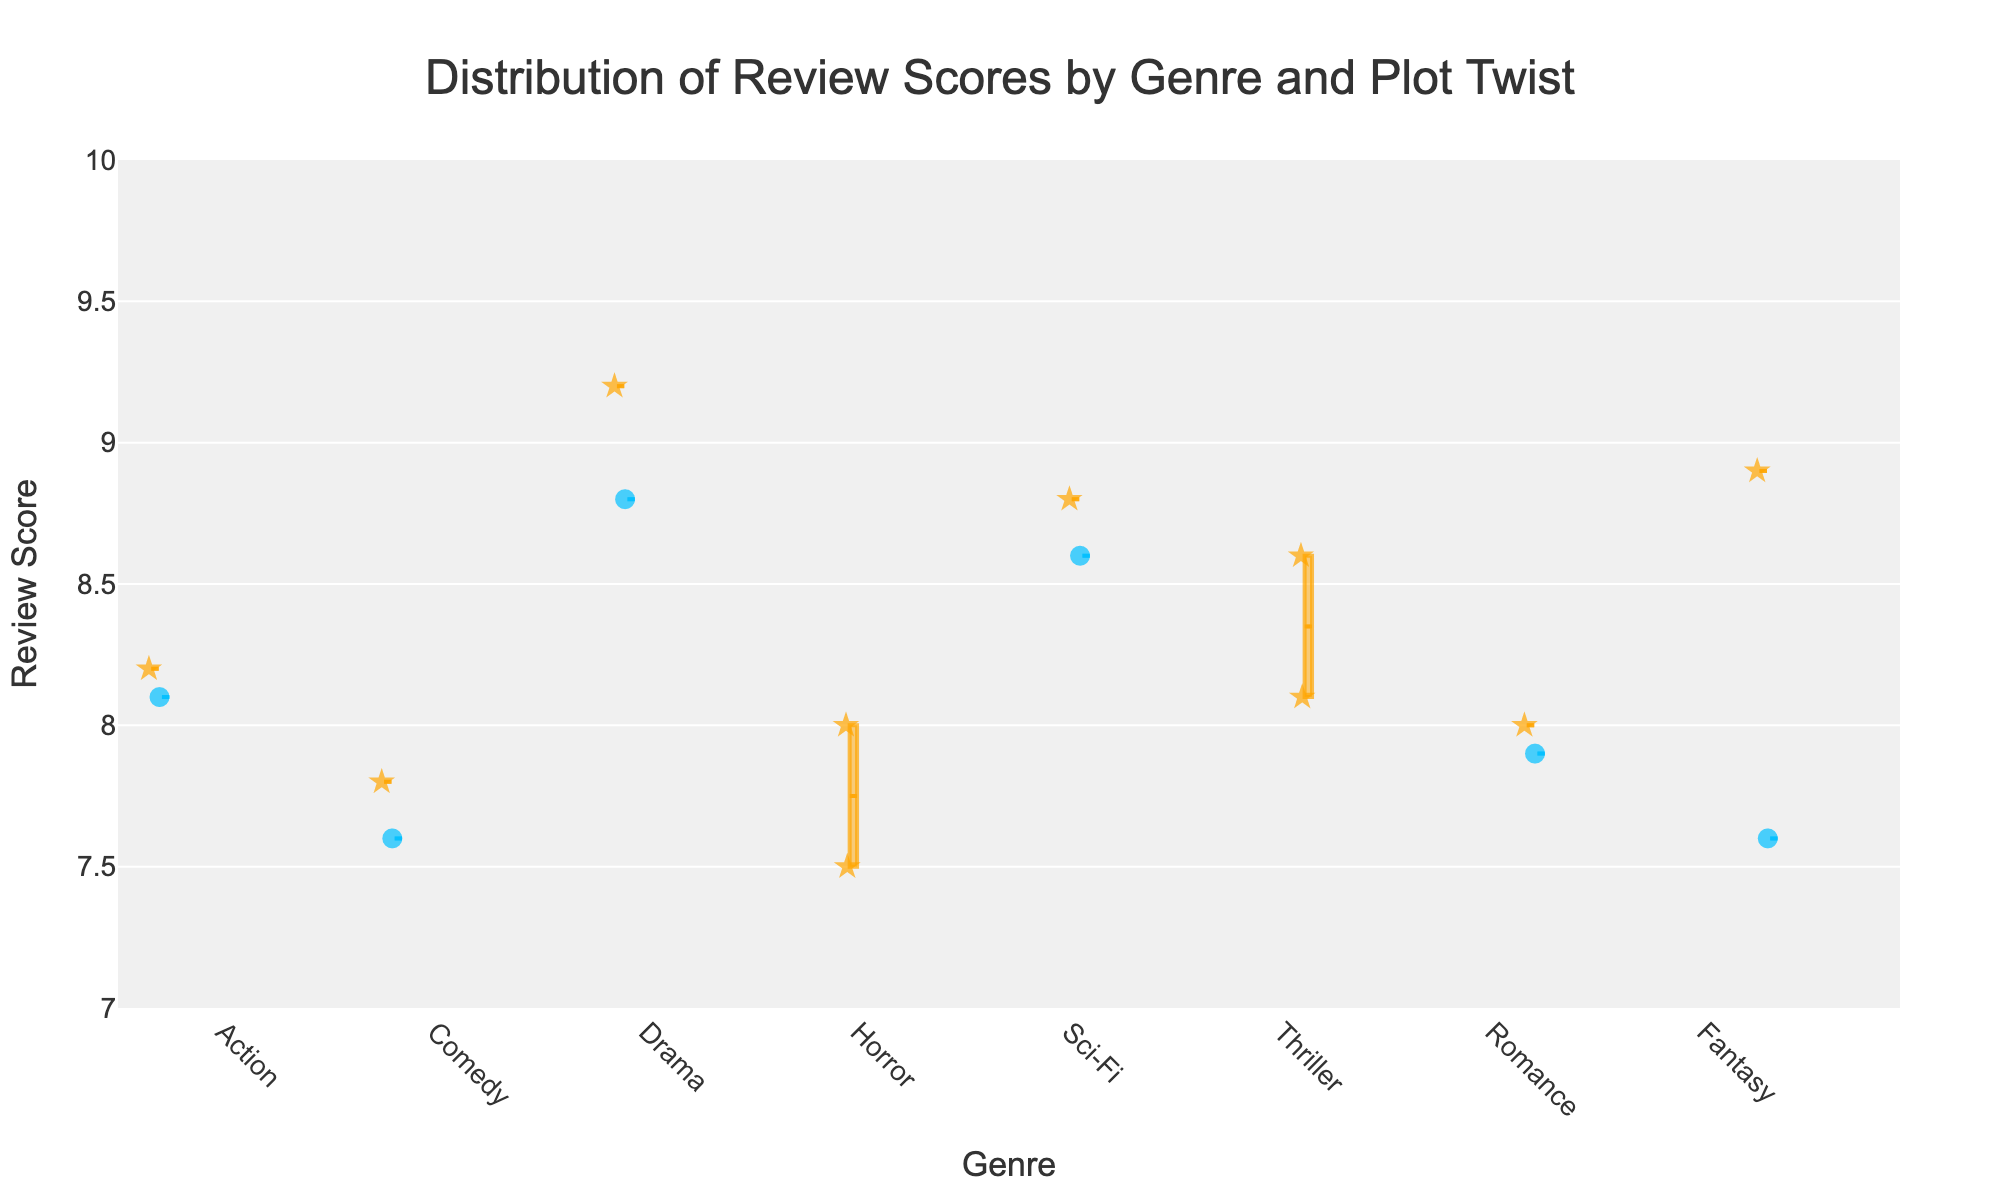What is the overall title of the figure? The title is usually found at the top of the figure, summarizing its content. In this case, the title is centered and reads: "Distribution of Review Scores by Genre and Plot Twist".
Answer: Distribution of Review Scores by Genre and Plot Twist What are the two possible categories for the legend item "Contains Plot Twist"? The legend indicates the categories for whether a film has a plot twist or not. These categories are shown as "Yes" and "No".
Answer: Yes, No What color represents films with plot twists? The figure uses different colors to distinguish between films with and without plot twists. Films with plot twists are marked with an orange shade.
Answer: Orange Which genre has the highest median review score for films with plot twists? To find the genre with the highest median review score for films with plot twists, look at the central line within the orange-colored boxes. The Drama genre, represented by The Godfather (9.2), has the highest median.
Answer: Drama How do review scores for films without plot twists compare across genres? For comparison, look at the blue-colored boxes and their positions along the Review Score axis. Sci-Fi (8.6 median for Interstellar) and Drama (8.8 median for Forrest Gump) are the highest without plot twists.
Answer: Sci-Fi and Drama What is the range of review scores for the Comedy genre with plot twists? Look at the box representing Comedy in the orange shade. The box's upper and lower extremes depict the range of review scores; here, it ranges between 7.6 and 7.8.
Answer: 7.6 to 7.8 Which genre shows the greatest spread in review scores for films with plot twists? The spread is observed by looking at the length of the boxes. In this figure, the Thriller genre shows the broadest spread, spanning from the lower whisker (around 8.1) to the upper whisker (around 8.6).
Answer: Thriller Which genre has a more consistent review score regardless of plot twists? Consistency can be measured by the length of the boxes and whiskers. The Comedy genre shows relatively short boxes and whiskers, indicating more consistent review scores, regardless of plot twists.
Answer: Comedy Does the presence of a plot twist seem to generally improve review scores within the Sci-Fi genre? Look at the comparison within the Sci-Fi genre box plots, where films with plot twists are in orange and those without are in blue. The median score for Sci-Fi films with plot twists appears to be higher (8.8 for Inception) compared to those without (8.6 for Interstellar), suggesting an improvement.
Answer: Yes 